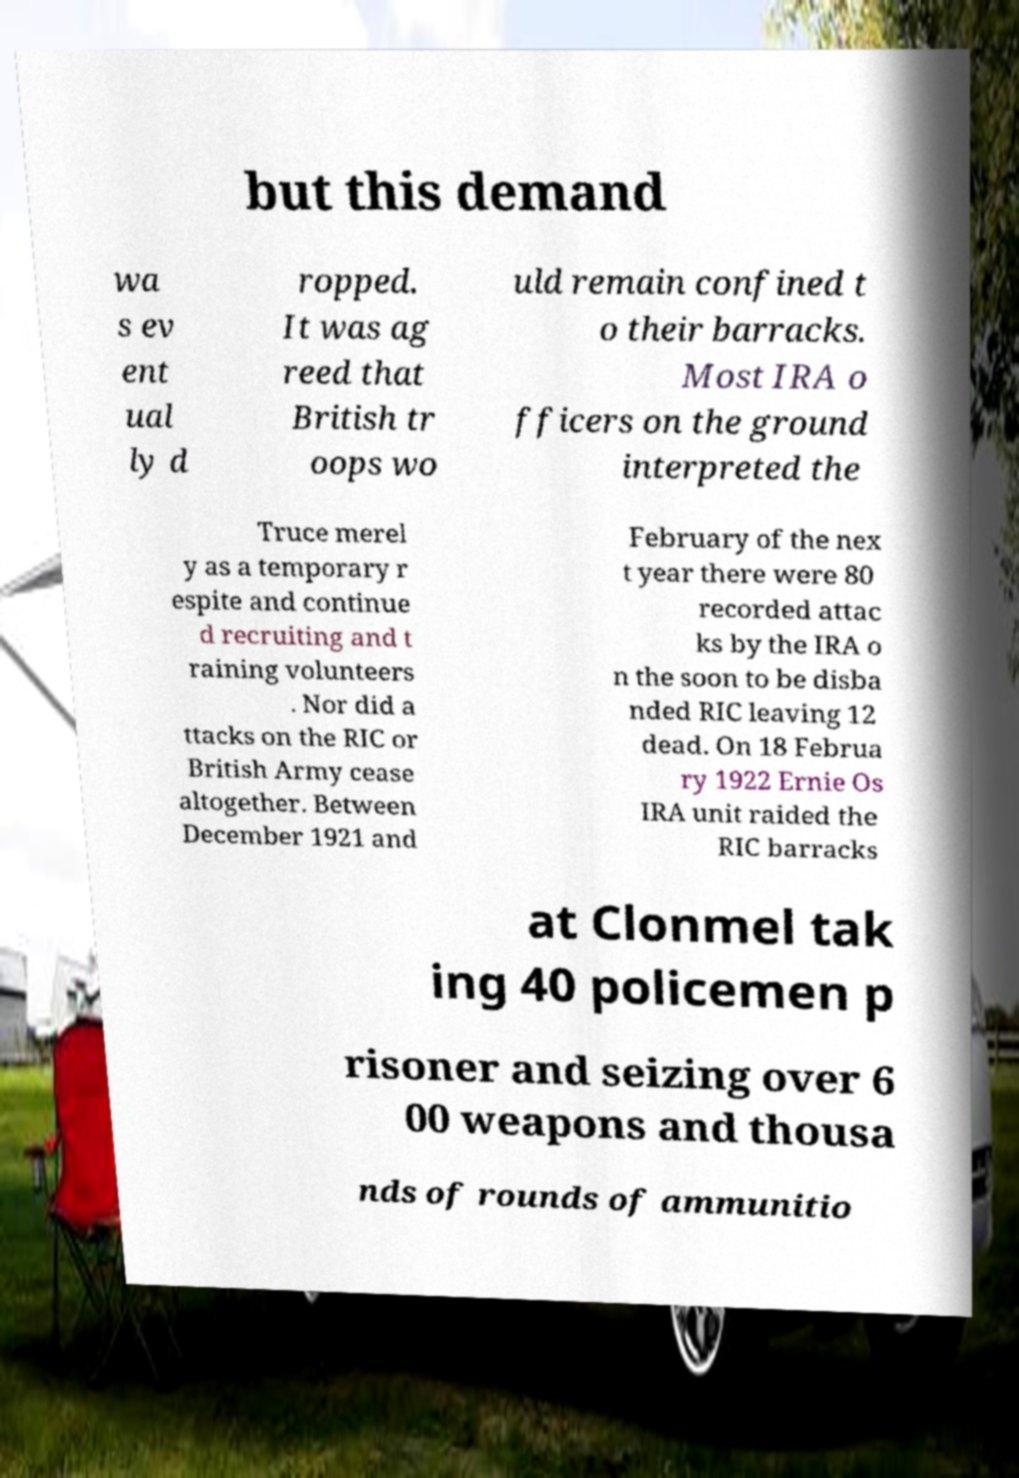There's text embedded in this image that I need extracted. Can you transcribe it verbatim? but this demand wa s ev ent ual ly d ropped. It was ag reed that British tr oops wo uld remain confined t o their barracks. Most IRA o fficers on the ground interpreted the Truce merel y as a temporary r espite and continue d recruiting and t raining volunteers . Nor did a ttacks on the RIC or British Army cease altogether. Between December 1921 and February of the nex t year there were 80 recorded attac ks by the IRA o n the soon to be disba nded RIC leaving 12 dead. On 18 Februa ry 1922 Ernie Os IRA unit raided the RIC barracks at Clonmel tak ing 40 policemen p risoner and seizing over 6 00 weapons and thousa nds of rounds of ammunitio 